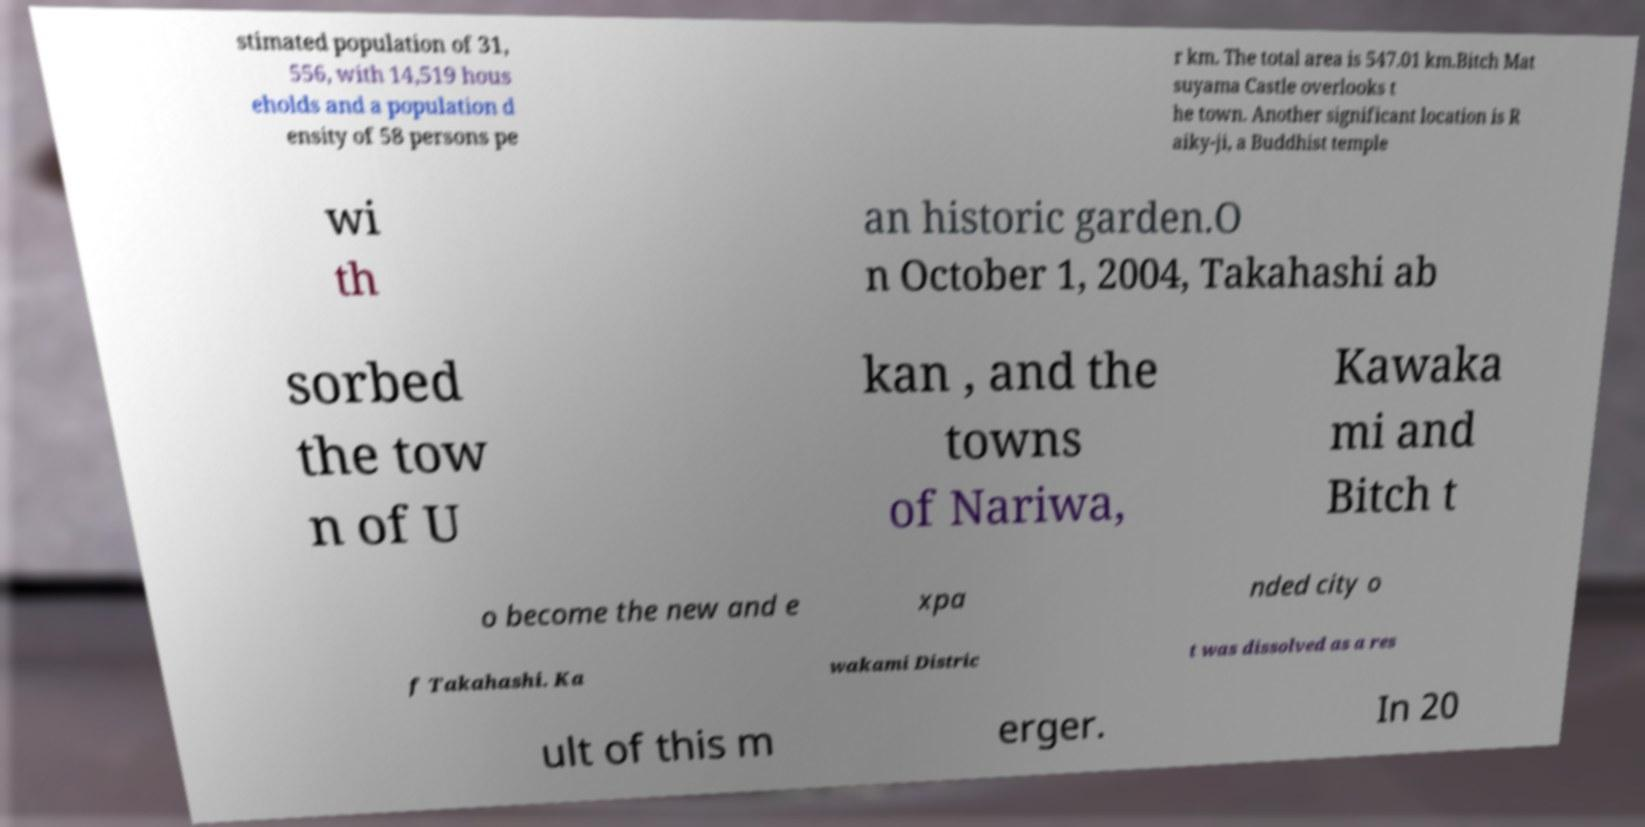Could you assist in decoding the text presented in this image and type it out clearly? stimated population of 31, 556, with 14,519 hous eholds and a population d ensity of 58 persons pe r km. The total area is 547.01 km.Bitch Mat suyama Castle overlooks t he town. Another significant location is R aiky-ji, a Buddhist temple wi th an historic garden.O n October 1, 2004, Takahashi ab sorbed the tow n of U kan , and the towns of Nariwa, Kawaka mi and Bitch t o become the new and e xpa nded city o f Takahashi. Ka wakami Distric t was dissolved as a res ult of this m erger. In 20 